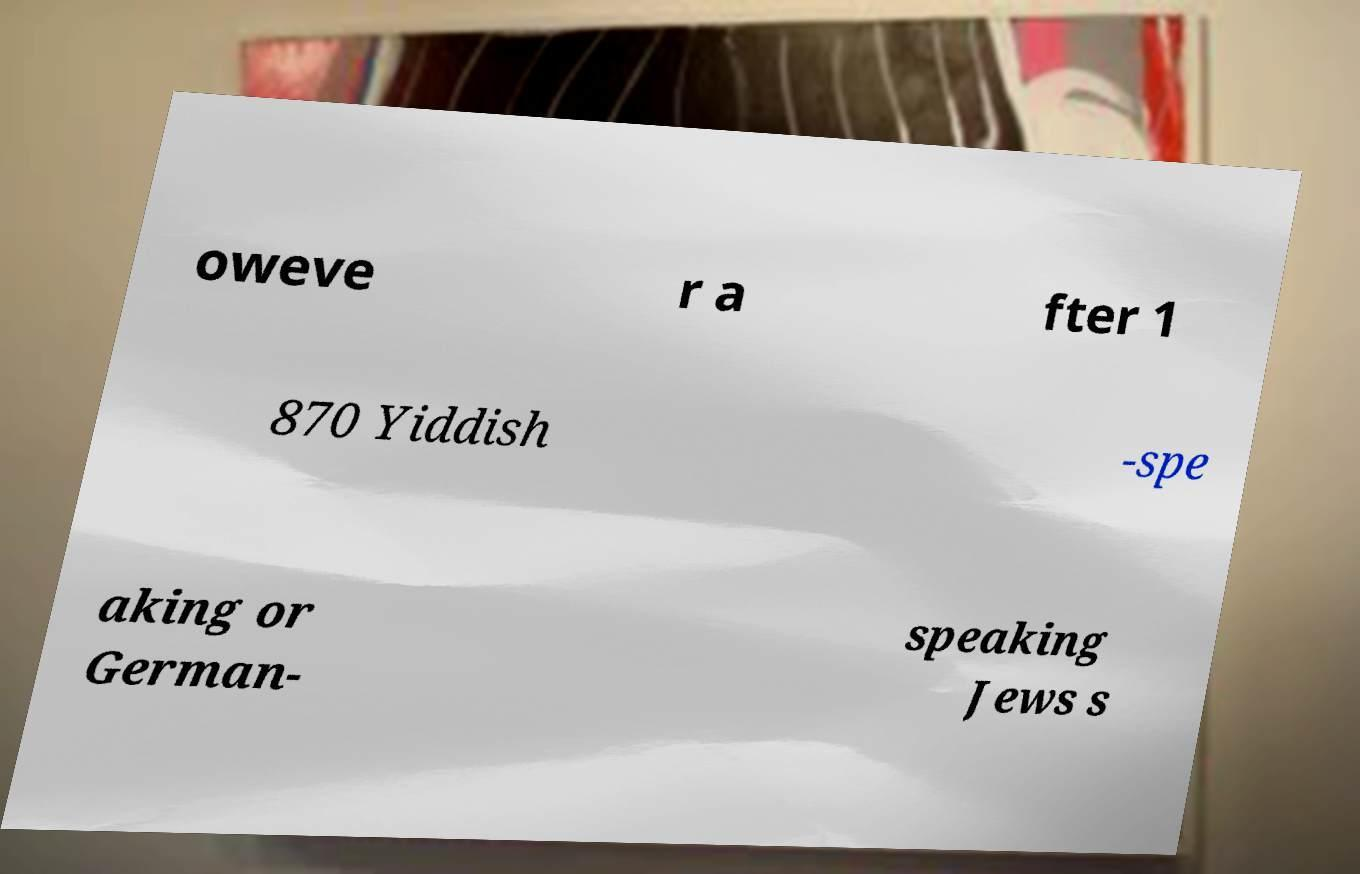For documentation purposes, I need the text within this image transcribed. Could you provide that? oweve r a fter 1 870 Yiddish -spe aking or German- speaking Jews s 